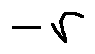Convert formula to latex. <formula><loc_0><loc_0><loc_500><loc_500>- r</formula> 